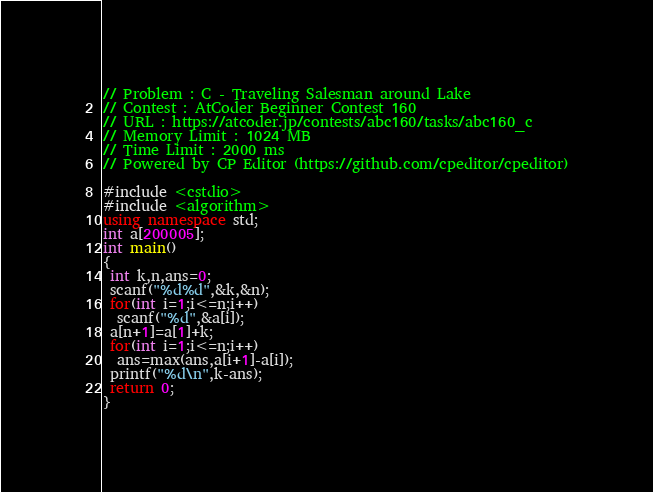<code> <loc_0><loc_0><loc_500><loc_500><_C++_>// Problem : C - Traveling Salesman around Lake
// Contest : AtCoder Beginner Contest 160
// URL : https://atcoder.jp/contests/abc160/tasks/abc160_c
// Memory Limit : 1024 MB
// Time Limit : 2000 ms
// Powered by CP Editor (https://github.com/cpeditor/cpeditor)

#include <cstdio>
#include <algorithm>
using namespace std;
int a[200005];
int main()
{
 int k,n,ans=0;
 scanf("%d%d",&k,&n);
 for(int i=1;i<=n;i++)
  scanf("%d",&a[i]);
 a[n+1]=a[1]+k;
 for(int i=1;i<=n;i++)
  ans=max(ans,a[i+1]-a[i]);
 printf("%d\n",k-ans);
 return 0;
}</code> 